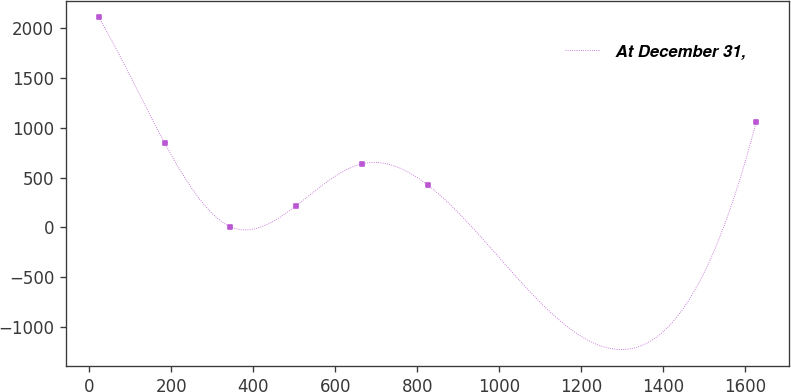Convert chart. <chart><loc_0><loc_0><loc_500><loc_500><line_chart><ecel><fcel>At December 31,<nl><fcel>22.88<fcel>2105.89<nl><fcel>183.34<fcel>846.73<nl><fcel>343.8<fcel>7.29<nl><fcel>504.26<fcel>217.15<nl><fcel>664.72<fcel>636.87<nl><fcel>825.18<fcel>427.01<nl><fcel>1627.5<fcel>1056.59<nl></chart> 